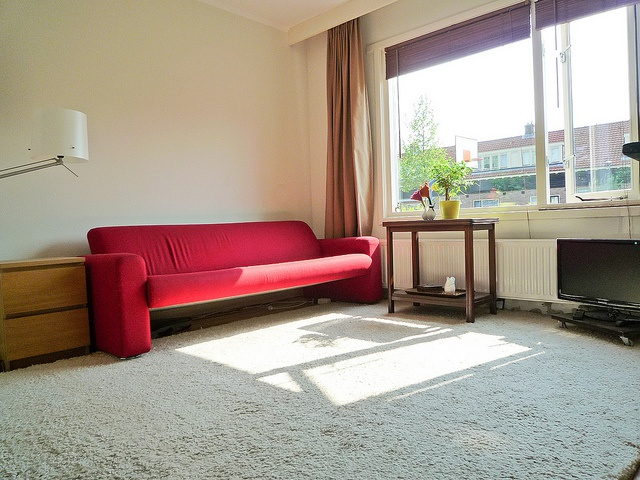Describe the objects in this image and their specific colors. I can see couch in olive, brown, maroon, and black tones, tv in olive, black, darkgreen, darkgray, and gray tones, potted plant in olive, khaki, ivory, and darkgray tones, vase in olive, khaki, and tan tones, and vase in olive, tan, gray, lightgray, and beige tones in this image. 